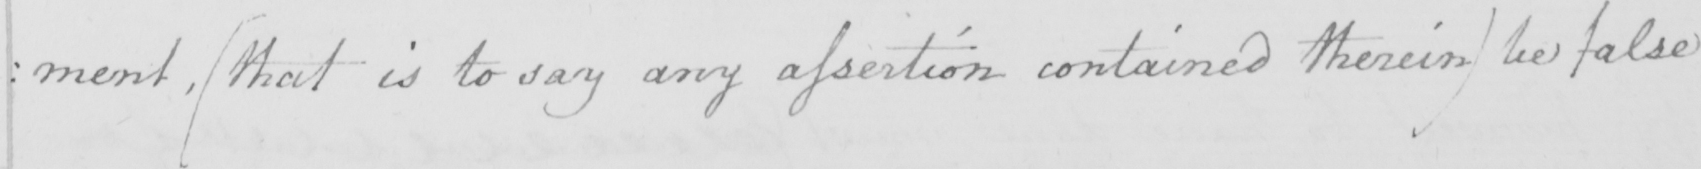What is written in this line of handwriting? : ment ,  ( that is to say any assertion contained therein )  be false 